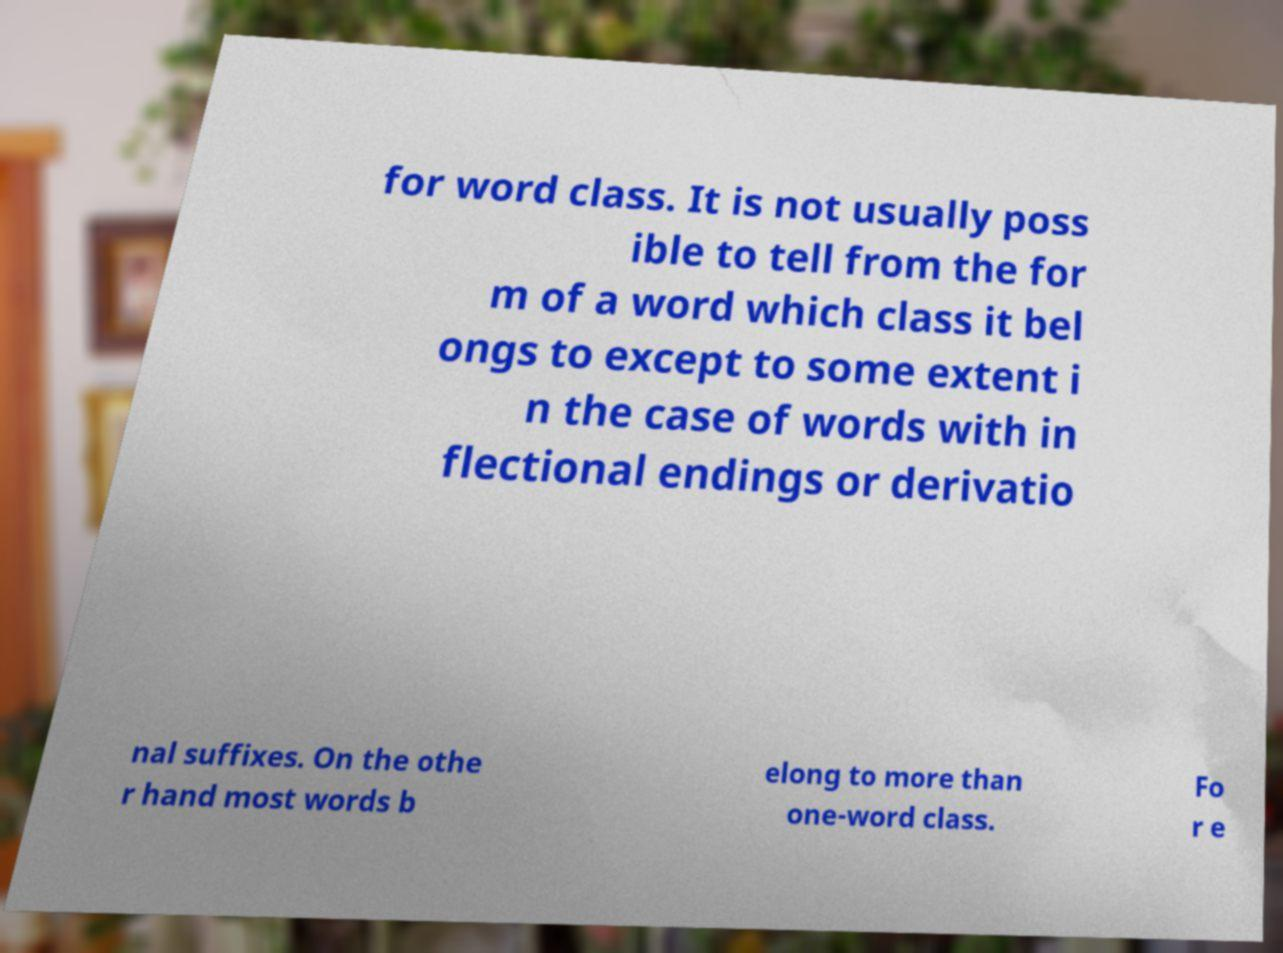Please read and relay the text visible in this image. What does it say? for word class. It is not usually poss ible to tell from the for m of a word which class it bel ongs to except to some extent i n the case of words with in flectional endings or derivatio nal suffixes. On the othe r hand most words b elong to more than one-word class. Fo r e 